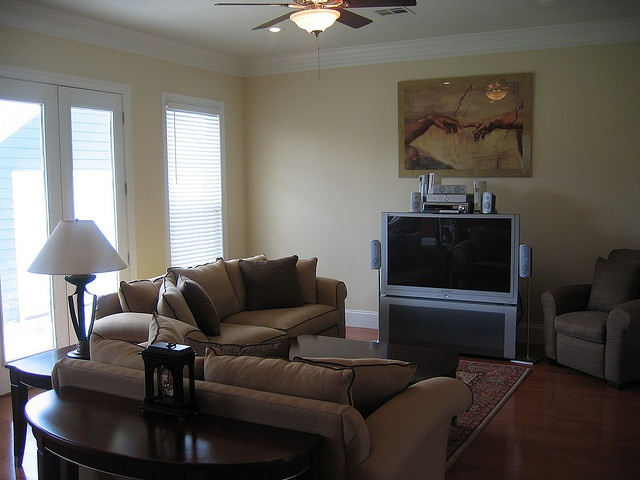Describe the objects in this image and their specific colors. I can see couch in black, gray, and maroon tones, tv in gray and black tones, chair in gray and black tones, clock in gray and black tones, and remote in gray, darkgray, and black tones in this image. 